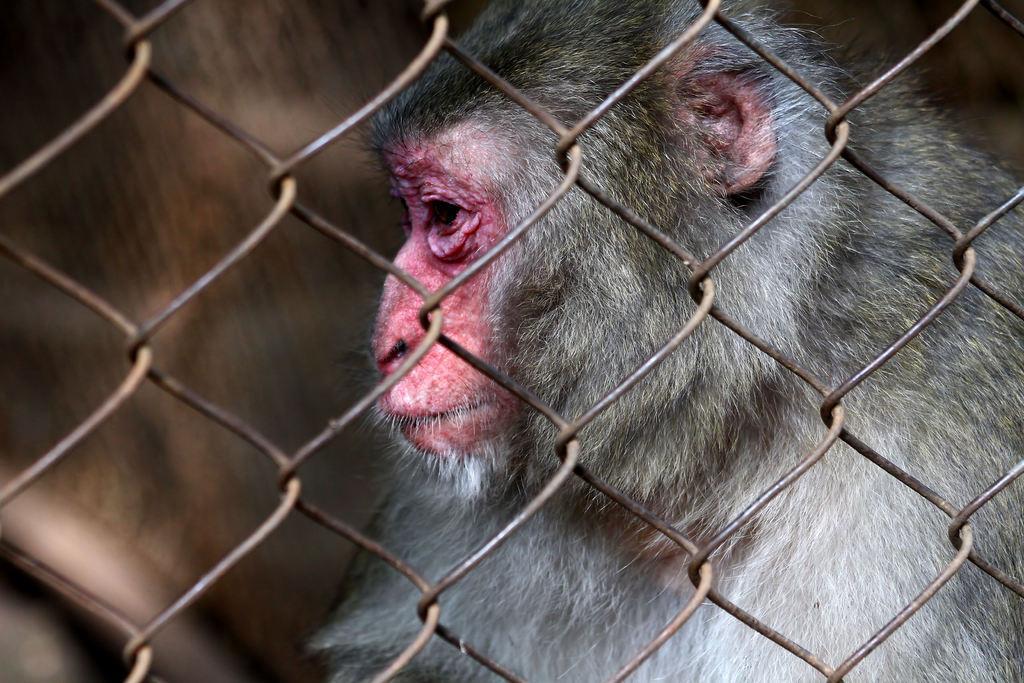Could you give a brief overview of what you see in this image? In this image in front there is a mesh. Behind the mesh there's a monkey. 